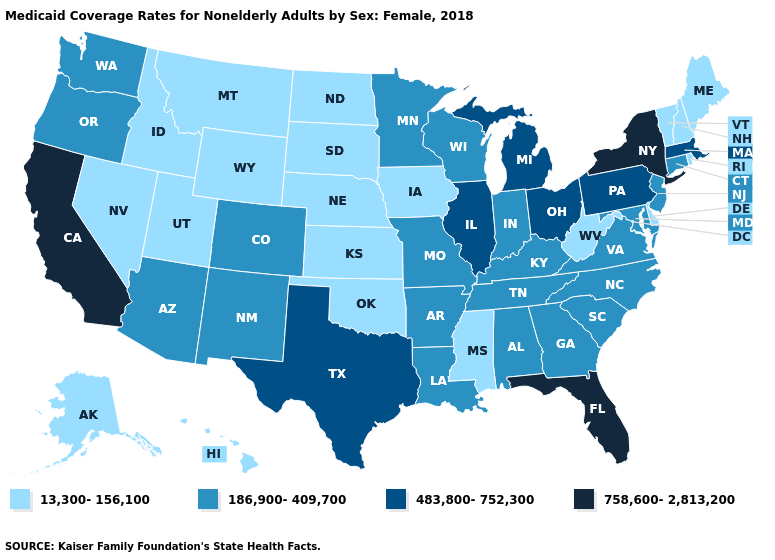Which states have the lowest value in the USA?
Answer briefly. Alaska, Delaware, Hawaii, Idaho, Iowa, Kansas, Maine, Mississippi, Montana, Nebraska, Nevada, New Hampshire, North Dakota, Oklahoma, Rhode Island, South Dakota, Utah, Vermont, West Virginia, Wyoming. What is the lowest value in the South?
Be succinct. 13,300-156,100. What is the value of New Hampshire?
Write a very short answer. 13,300-156,100. Name the states that have a value in the range 758,600-2,813,200?
Quick response, please. California, Florida, New York. What is the value of Michigan?
Short answer required. 483,800-752,300. What is the value of Wisconsin?
Quick response, please. 186,900-409,700. Which states have the lowest value in the USA?
Give a very brief answer. Alaska, Delaware, Hawaii, Idaho, Iowa, Kansas, Maine, Mississippi, Montana, Nebraska, Nevada, New Hampshire, North Dakota, Oklahoma, Rhode Island, South Dakota, Utah, Vermont, West Virginia, Wyoming. What is the value of Texas?
Be succinct. 483,800-752,300. Name the states that have a value in the range 758,600-2,813,200?
Give a very brief answer. California, Florida, New York. Which states have the lowest value in the USA?
Short answer required. Alaska, Delaware, Hawaii, Idaho, Iowa, Kansas, Maine, Mississippi, Montana, Nebraska, Nevada, New Hampshire, North Dakota, Oklahoma, Rhode Island, South Dakota, Utah, Vermont, West Virginia, Wyoming. Name the states that have a value in the range 13,300-156,100?
Be succinct. Alaska, Delaware, Hawaii, Idaho, Iowa, Kansas, Maine, Mississippi, Montana, Nebraska, Nevada, New Hampshire, North Dakota, Oklahoma, Rhode Island, South Dakota, Utah, Vermont, West Virginia, Wyoming. Name the states that have a value in the range 13,300-156,100?
Short answer required. Alaska, Delaware, Hawaii, Idaho, Iowa, Kansas, Maine, Mississippi, Montana, Nebraska, Nevada, New Hampshire, North Dakota, Oklahoma, Rhode Island, South Dakota, Utah, Vermont, West Virginia, Wyoming. Does Illinois have the same value as Nebraska?
Quick response, please. No. What is the lowest value in the USA?
Keep it brief. 13,300-156,100. 